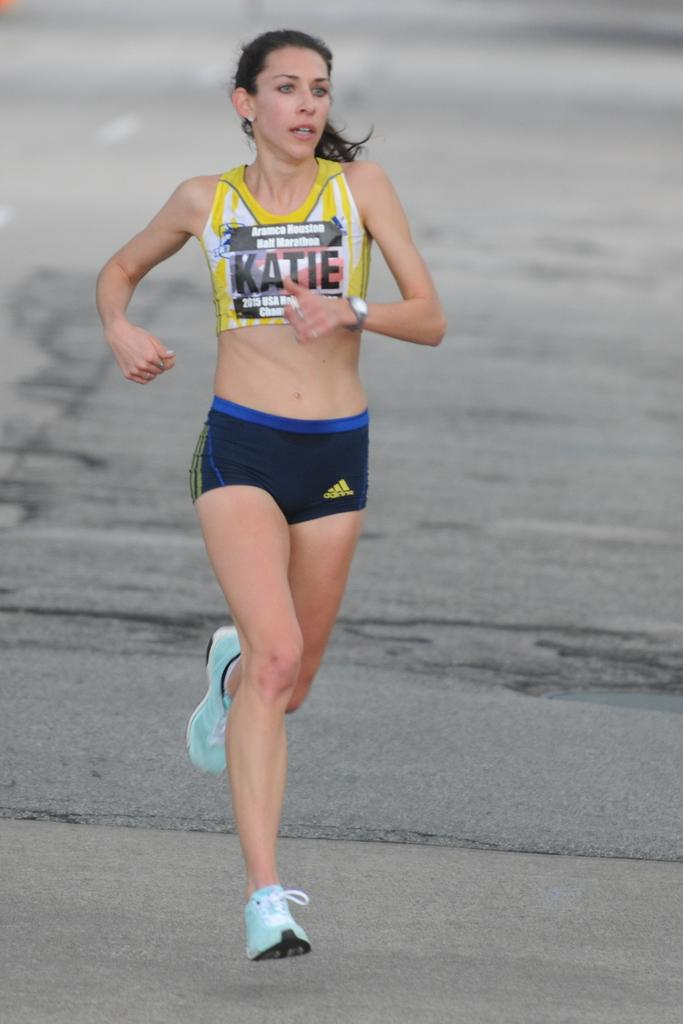<image>
Write a terse but informative summary of the picture. a lady with the name Katie on her outfit 